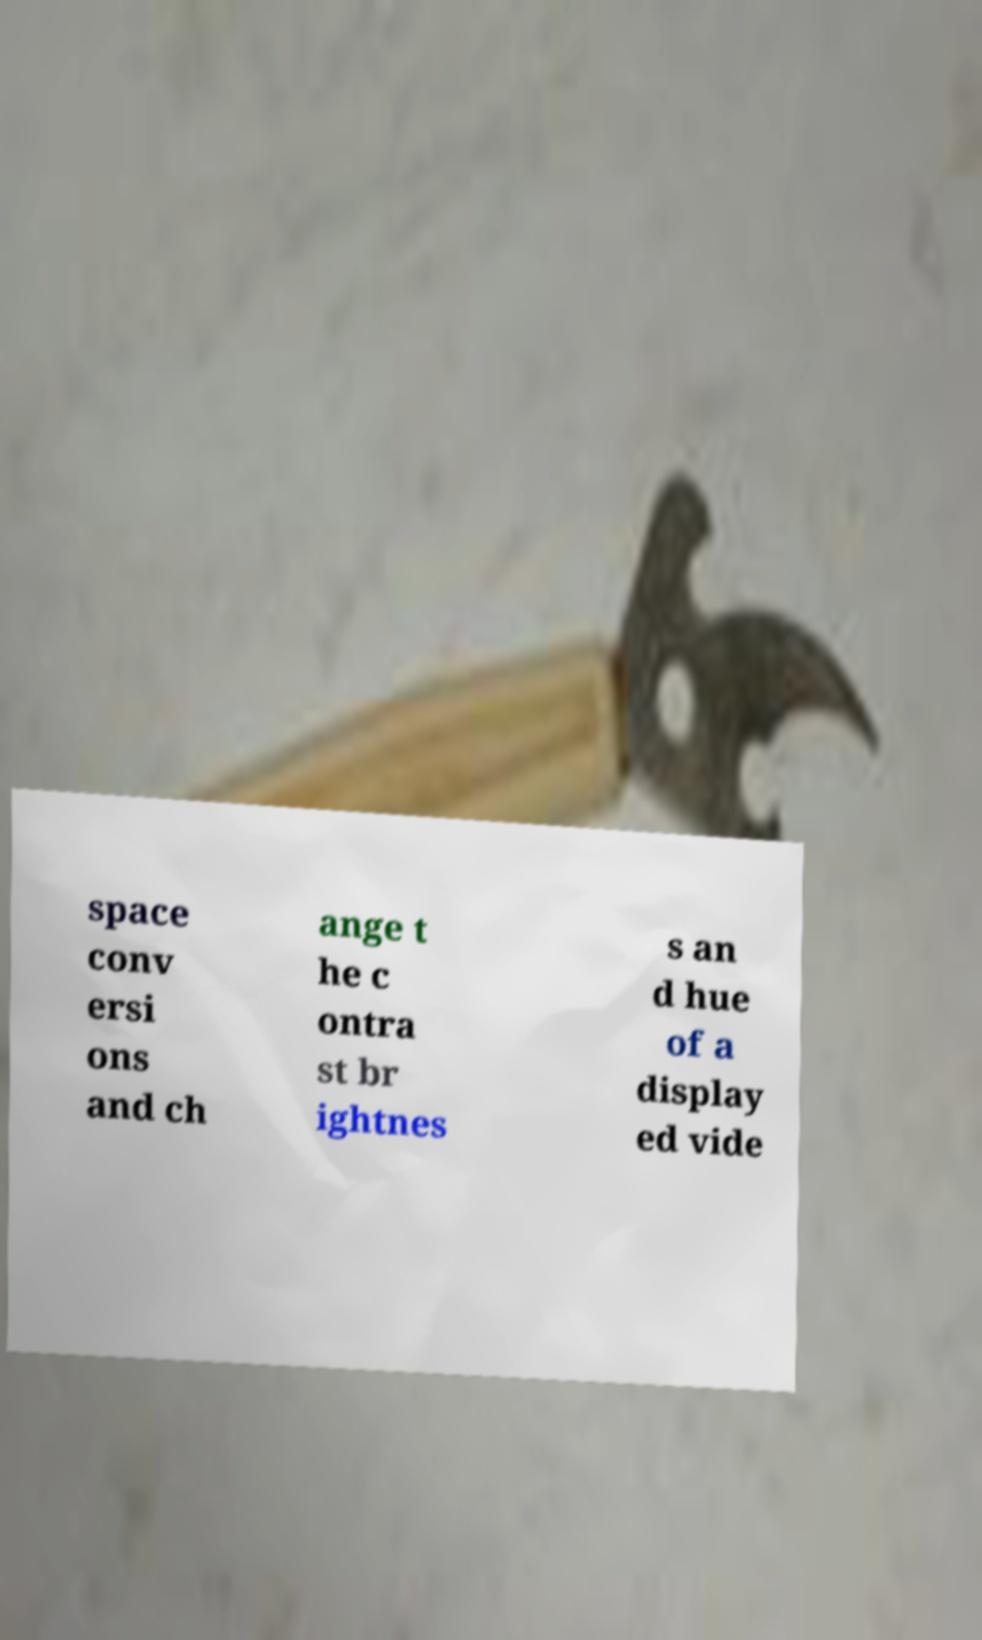There's text embedded in this image that I need extracted. Can you transcribe it verbatim? space conv ersi ons and ch ange t he c ontra st br ightnes s an d hue of a display ed vide 